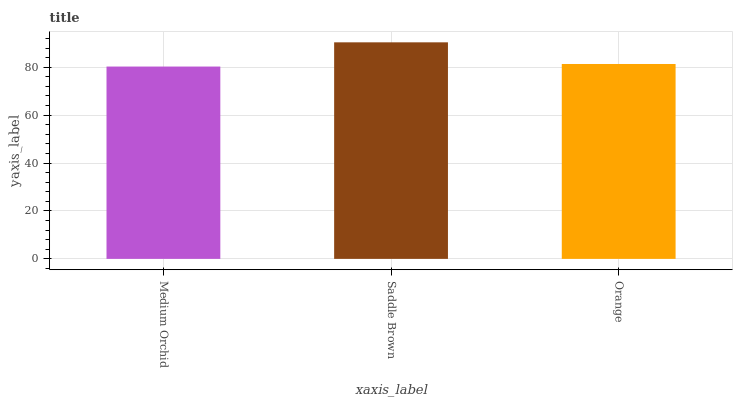Is Medium Orchid the minimum?
Answer yes or no. Yes. Is Saddle Brown the maximum?
Answer yes or no. Yes. Is Orange the minimum?
Answer yes or no. No. Is Orange the maximum?
Answer yes or no. No. Is Saddle Brown greater than Orange?
Answer yes or no. Yes. Is Orange less than Saddle Brown?
Answer yes or no. Yes. Is Orange greater than Saddle Brown?
Answer yes or no. No. Is Saddle Brown less than Orange?
Answer yes or no. No. Is Orange the high median?
Answer yes or no. Yes. Is Orange the low median?
Answer yes or no. Yes. Is Saddle Brown the high median?
Answer yes or no. No. Is Medium Orchid the low median?
Answer yes or no. No. 